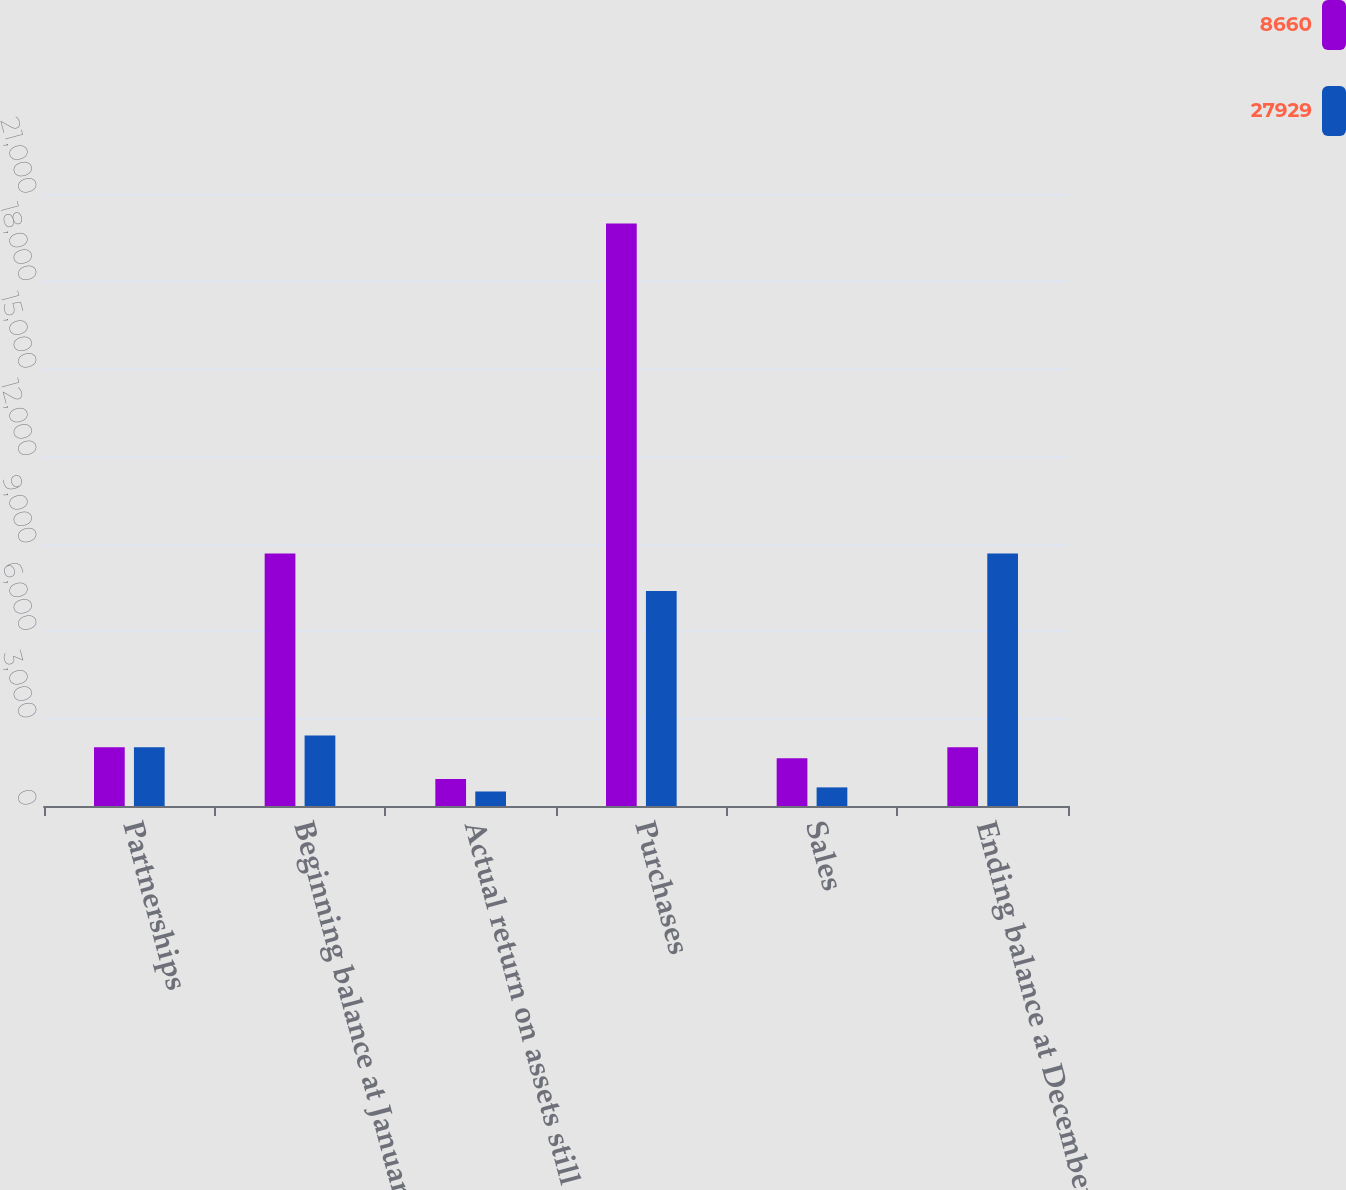<chart> <loc_0><loc_0><loc_500><loc_500><stacked_bar_chart><ecel><fcel>Partnerships<fcel>Beginning balance at January 1<fcel>Actual return on assets still<fcel>Purchases<fcel>Sales<fcel>Ending balance at December 31<nl><fcel>8660<fcel>2014<fcel>8660<fcel>927<fcel>19984<fcel>1642<fcel>2014<nl><fcel>27929<fcel>2013<fcel>2419<fcel>498<fcel>7377<fcel>638<fcel>8660<nl></chart> 